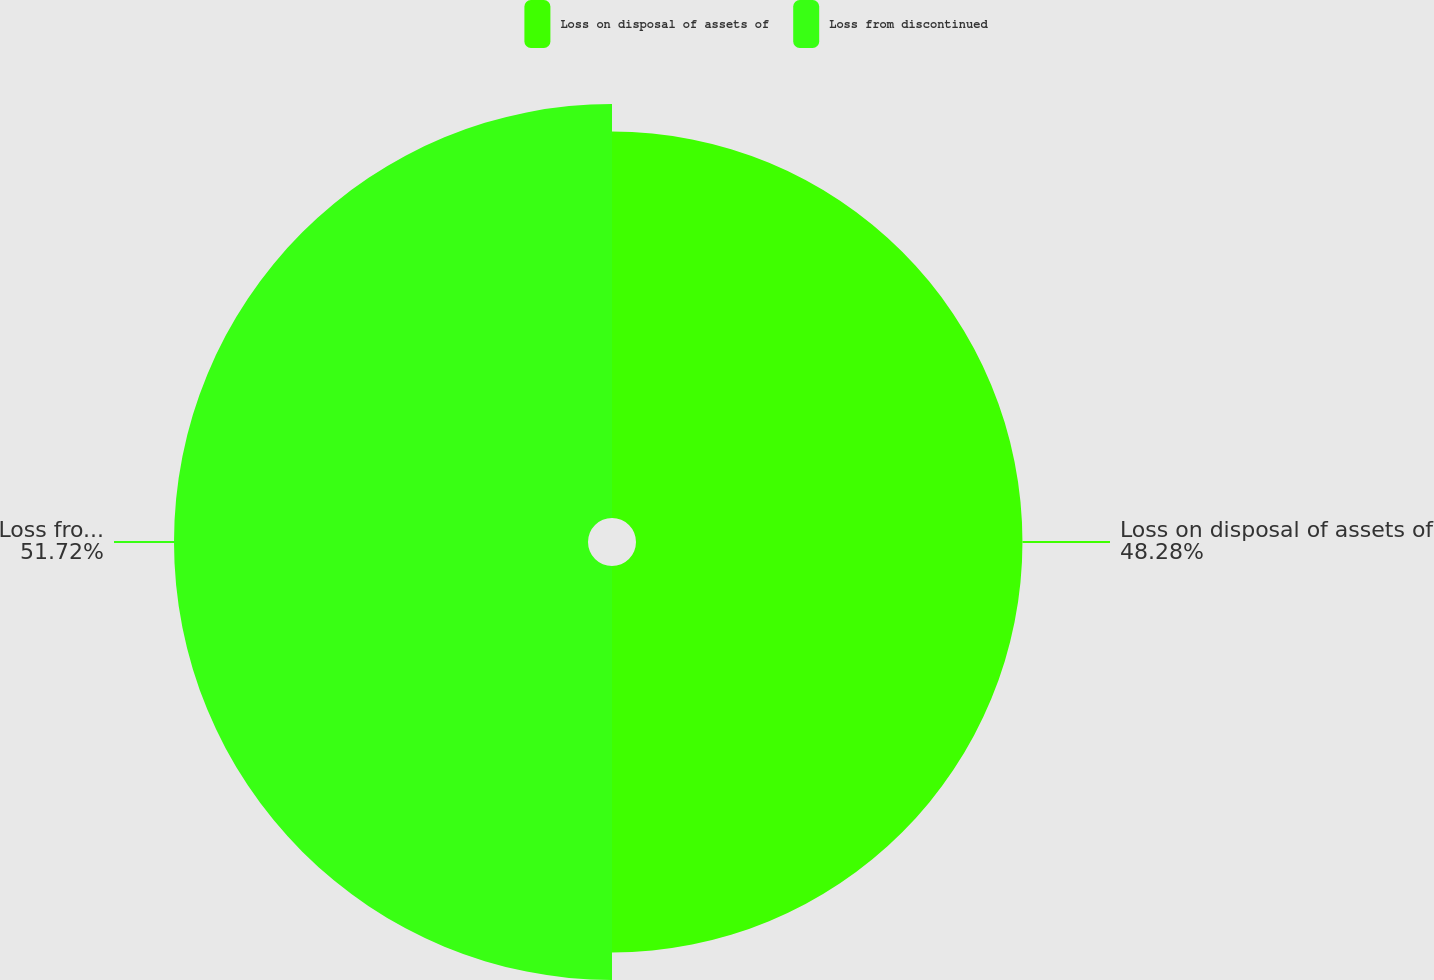<chart> <loc_0><loc_0><loc_500><loc_500><pie_chart><fcel>Loss on disposal of assets of<fcel>Loss from discontinued<nl><fcel>48.28%<fcel>51.72%<nl></chart> 